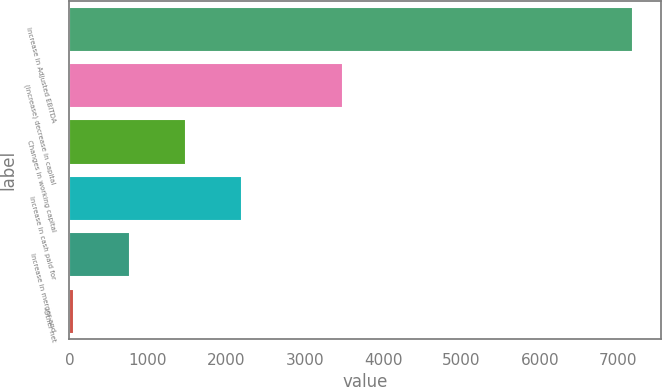Convert chart to OTSL. <chart><loc_0><loc_0><loc_500><loc_500><bar_chart><fcel>Increase in Adjusted EBITDA<fcel>(Increase) decrease in capital<fcel>Changes in working capital<fcel>Increase in cash paid for<fcel>Increase in merger and<fcel>Other net<nl><fcel>7186<fcel>3485<fcel>1486.8<fcel>2199.2<fcel>774.4<fcel>62<nl></chart> 